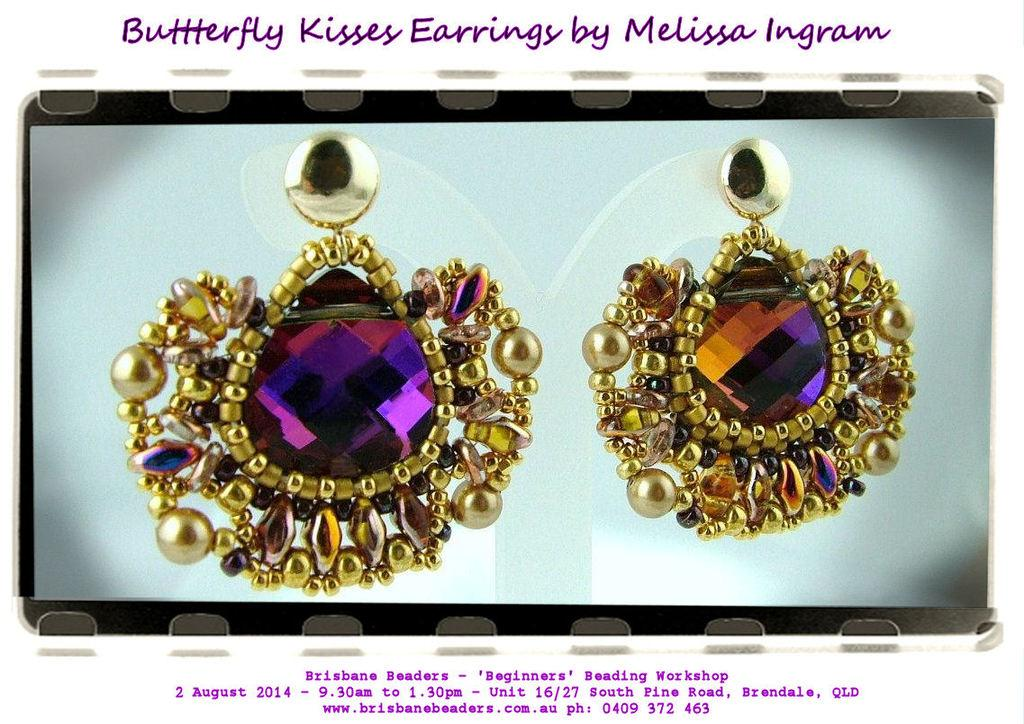<image>
Share a concise interpretation of the image provided. Butterfly Kisses earrings have large amethyst stones surrounded by gold beading. 